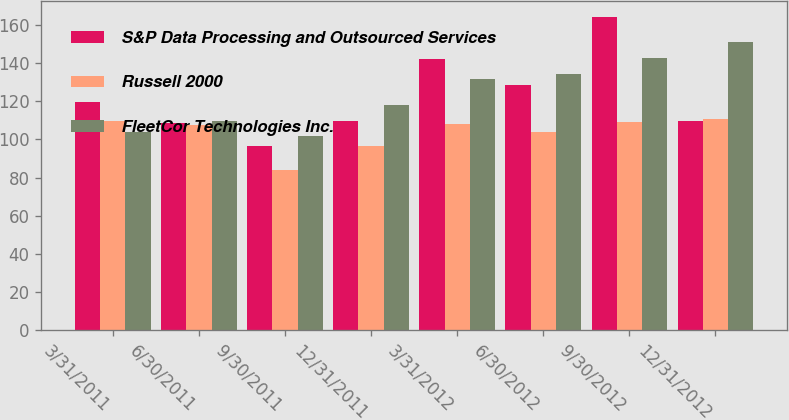Convert chart. <chart><loc_0><loc_0><loc_500><loc_500><stacked_bar_chart><ecel><fcel>3/31/2011<fcel>6/30/2011<fcel>9/30/2011<fcel>12/31/2011<fcel>3/31/2012<fcel>6/30/2012<fcel>9/30/2012<fcel>12/31/2012<nl><fcel>S&P Data Processing and Outsourced Services<fcel>119.85<fcel>108.77<fcel>96.37<fcel>109.61<fcel>142.28<fcel>128.59<fcel>164.4<fcel>109.64<nl><fcel>Russell 2000<fcel>109.79<fcel>107.69<fcel>83.84<fcel>96.43<fcel>108.06<fcel>103.92<fcel>108.99<fcel>110.54<nl><fcel>FleetCor Technologies Inc.<fcel>103.76<fcel>109.64<fcel>101.69<fcel>117.84<fcel>131.45<fcel>134.18<fcel>142.48<fcel>150.84<nl></chart> 